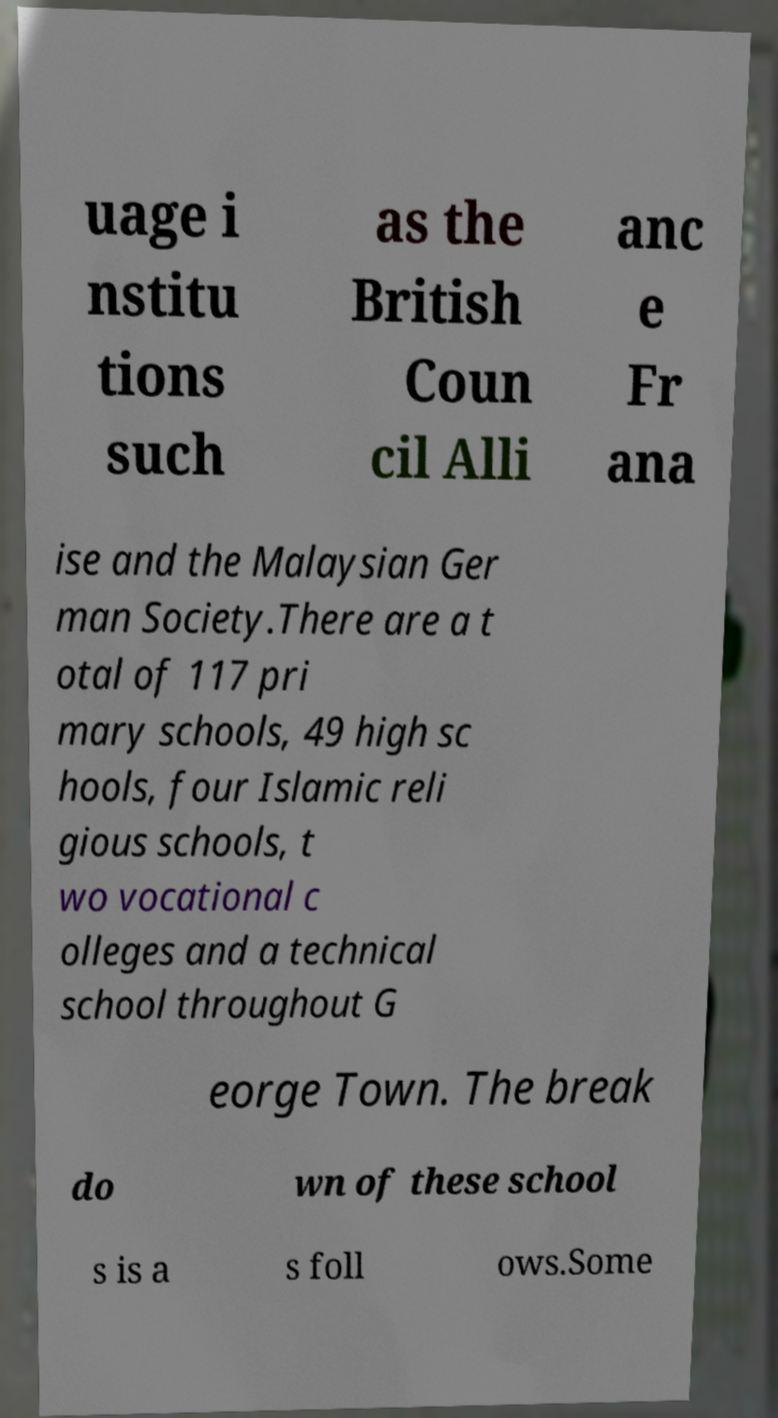What messages or text are displayed in this image? I need them in a readable, typed format. uage i nstitu tions such as the British Coun cil Alli anc e Fr ana ise and the Malaysian Ger man Society.There are a t otal of 117 pri mary schools, 49 high sc hools, four Islamic reli gious schools, t wo vocational c olleges and a technical school throughout G eorge Town. The break do wn of these school s is a s foll ows.Some 